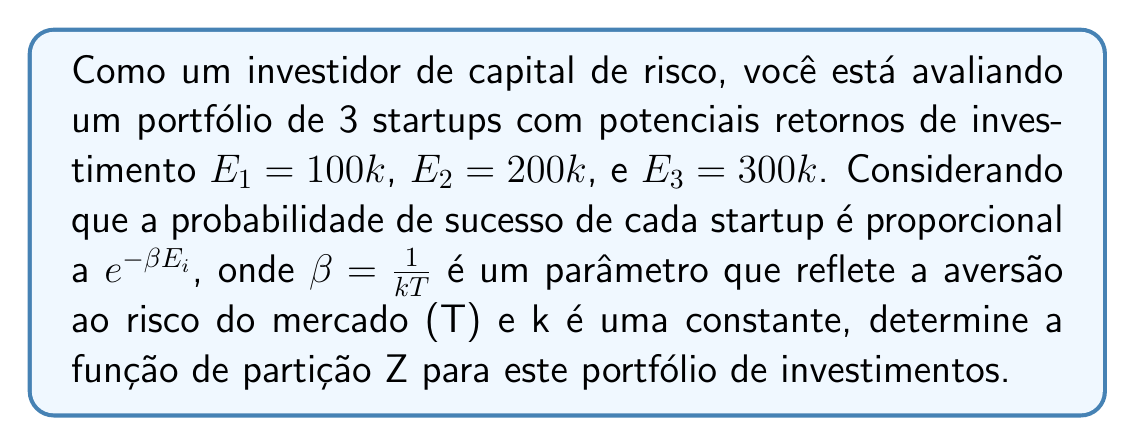What is the answer to this math problem? Para determinar a função de partição Z para este portfólio de investimentos, seguiremos os seguintes passos:

1) A função de partição Z é definida como a soma dos fatores de Boltzmann para todos os estados possíveis do sistema. No contexto de investimentos, cada startup representa um estado possível.

2) O fator de Boltzmann para cada startup é dado por $e^{-\beta E_i}$, onde $E_i$ é o retorno potencial do investimento.

3) Portanto, a função de partição Z será a soma dos fatores de Boltzmann para as três startups:

   $$Z = e^{-\beta E_1} + e^{-\beta E_2} + e^{-\beta E_3}$$

4) Substituindo os valores dados:

   $$Z = e^{-\beta (100k)} + e^{-\beta (200k)} + e^{-\beta (300k)}$$

5) Fatorando k:

   $$Z = e^{-100k\beta} + e^{-200k\beta} + e^{-300k\beta}$$

6) Esta é a forma final da função de partição para este portfólio de investimentos.
Answer: $$Z = e^{-100k\beta} + e^{-200k\beta} + e^{-300k\beta}$$ 